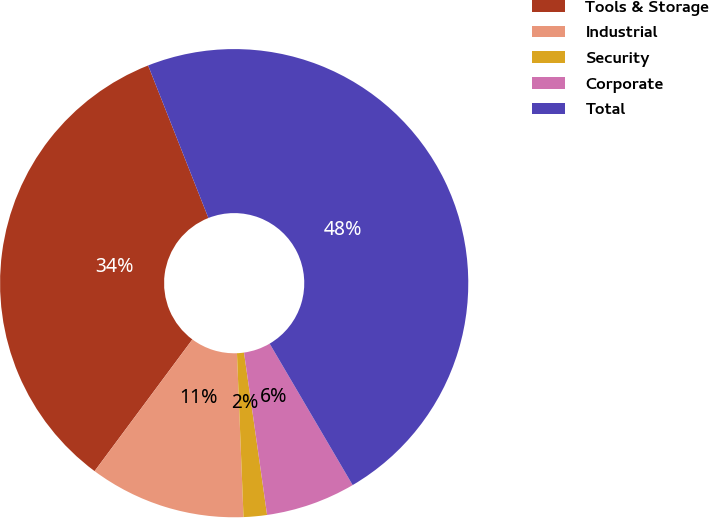<chart> <loc_0><loc_0><loc_500><loc_500><pie_chart><fcel>Tools & Storage<fcel>Industrial<fcel>Security<fcel>Corporate<fcel>Total<nl><fcel>33.84%<fcel>10.8%<fcel>1.61%<fcel>6.2%<fcel>47.54%<nl></chart> 